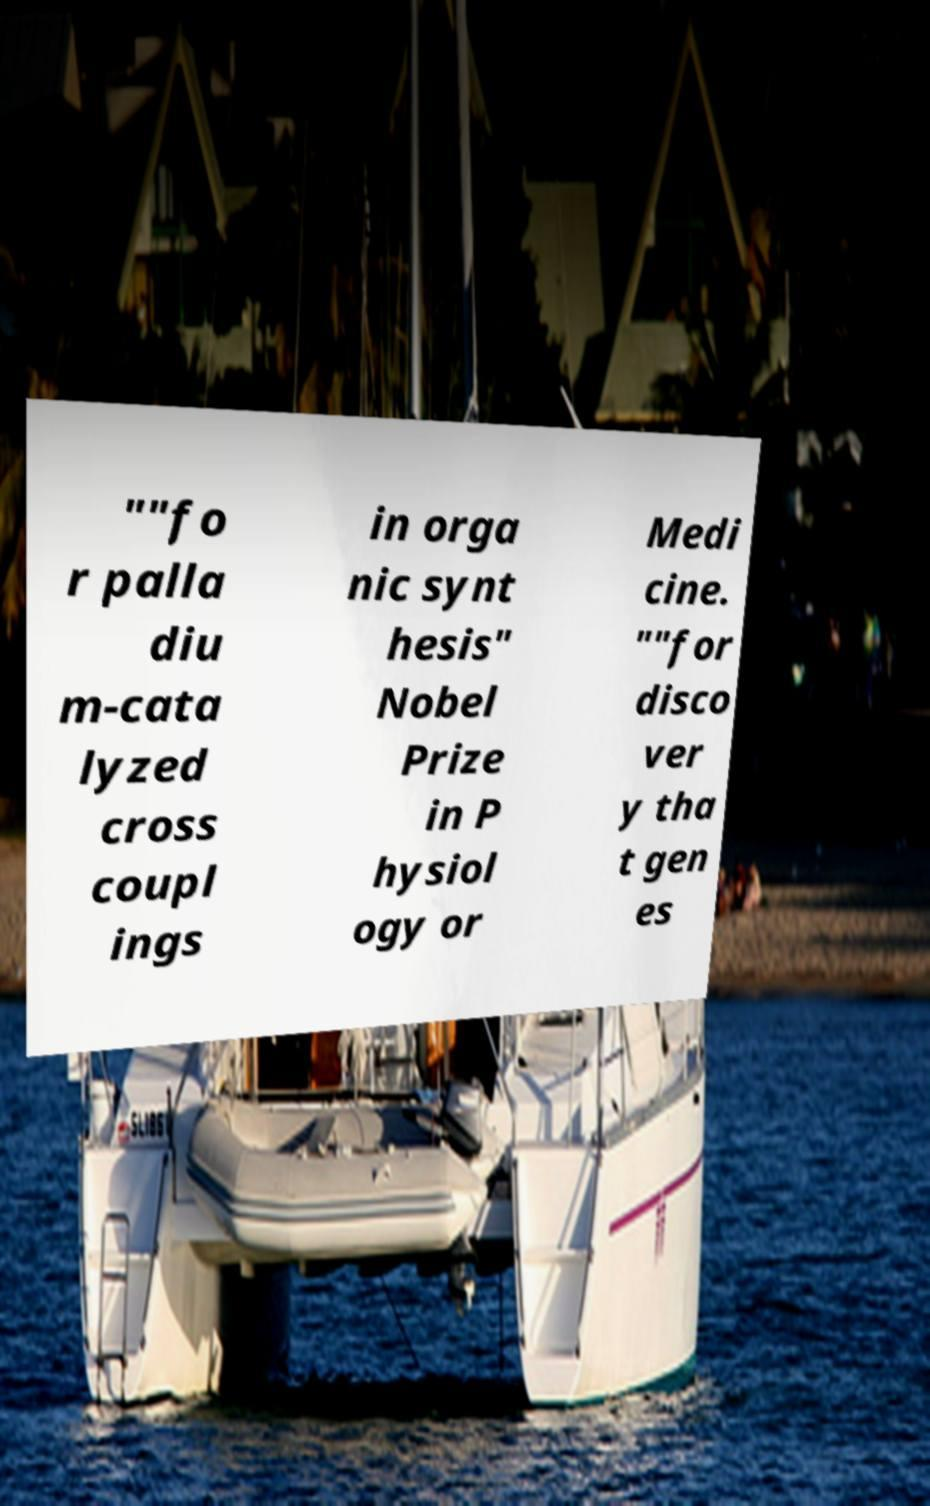Please identify and transcribe the text found in this image. ""fo r palla diu m-cata lyzed cross coupl ings in orga nic synt hesis" Nobel Prize in P hysiol ogy or Medi cine. ""for disco ver y tha t gen es 